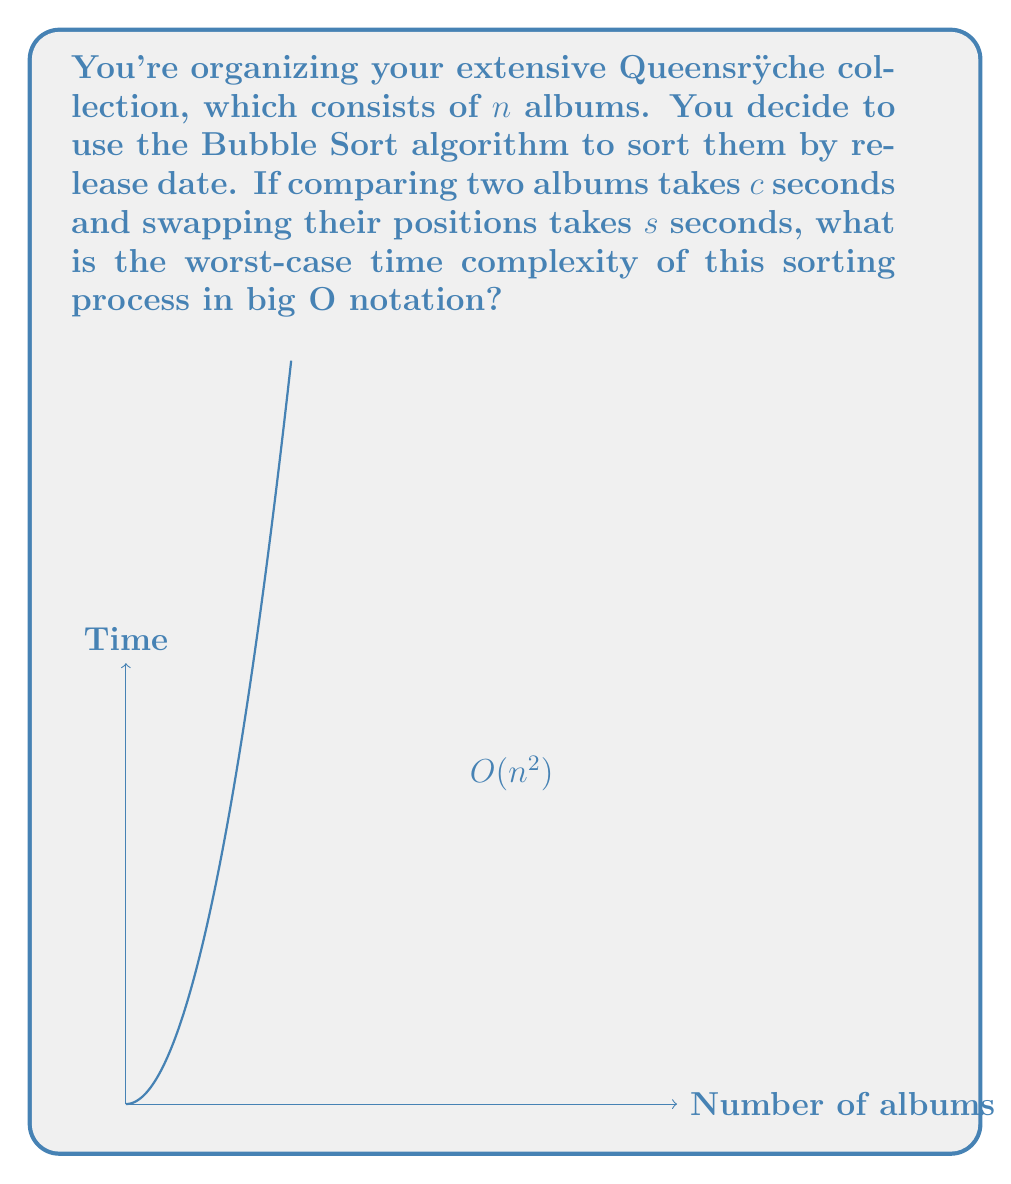Solve this math problem. Let's analyze this step-by-step:

1) Bubble Sort makes multiple passes through the list, comparing adjacent elements and swapping them if they're in the wrong order.

2) In the worst-case scenario (when the list is in reverse order):
   - The outer loop runs $n-1$ times
   - For each outer loop, the inner loop runs $n-i-1$ times, where $i$ is the current iteration of the outer loop

3) The total number of comparisons is:

   $$\sum_{i=0}^{n-2} (n-i-1) = \frac{n(n-1)}{2}$$

4) In the worst case, each comparison results in a swap. So the number of swaps is also $\frac{n(n-1)}{2}$

5) The total time is:

   $$T(n) = c \cdot \frac{n(n-1)}{2} + s \cdot \frac{n(n-1)}{2} = \frac{(c+s)n(n-1)}{2}$$

6) Expanding this:

   $$T(n) = \frac{(c+s)(n^2-n)}{2} = \frac{c+s}{2}n^2 - \frac{c+s}{2}n$$

7) In big O notation, we drop lower-order terms and constants. Therefore:

   $$T(n) = O(n^2)$$

This quadratic time complexity is represented by the parabolic curve in the graph, showing how the sorting time grows quickly as the number of albums increases.
Answer: $O(n^2)$ 